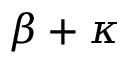Convert formula to latex. <formula><loc_0><loc_0><loc_500><loc_500>\beta + \kappa</formula> 